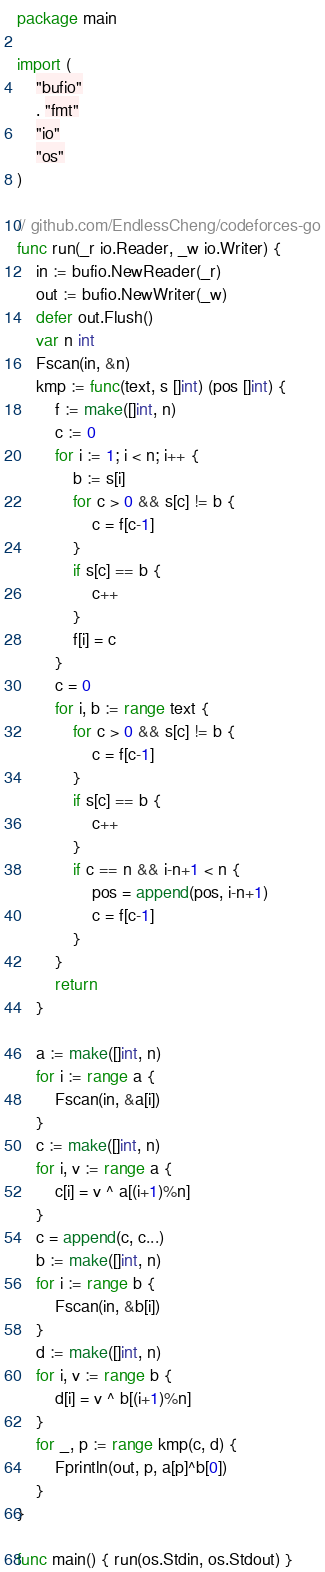Convert code to text. <code><loc_0><loc_0><loc_500><loc_500><_Go_>package main

import (
	"bufio"
	. "fmt"
	"io"
	"os"
)

// github.com/EndlessCheng/codeforces-go
func run(_r io.Reader, _w io.Writer) {
	in := bufio.NewReader(_r)
	out := bufio.NewWriter(_w)
	defer out.Flush()
	var n int
	Fscan(in, &n)
	kmp := func(text, s []int) (pos []int) {
		f := make([]int, n)
		c := 0
		for i := 1; i < n; i++ {
			b := s[i]
			for c > 0 && s[c] != b {
				c = f[c-1]
			}
			if s[c] == b {
				c++
			}
			f[i] = c
		}
		c = 0
		for i, b := range text {
			for c > 0 && s[c] != b {
				c = f[c-1]
			}
			if s[c] == b {
				c++
			}
			if c == n && i-n+1 < n {
				pos = append(pos, i-n+1)
				c = f[c-1]
			}
		}
		return
	}

	a := make([]int, n)
	for i := range a {
		Fscan(in, &a[i])
	}
	c := make([]int, n)
	for i, v := range a {
		c[i] = v ^ a[(i+1)%n]
	}
	c = append(c, c...)
	b := make([]int, n)
	for i := range b {
		Fscan(in, &b[i])
	}
	d := make([]int, n)
	for i, v := range b {
		d[i] = v ^ b[(i+1)%n]
	}
	for _, p := range kmp(c, d) {
		Fprintln(out, p, a[p]^b[0])
	}
}

func main() { run(os.Stdin, os.Stdout) }
</code> 